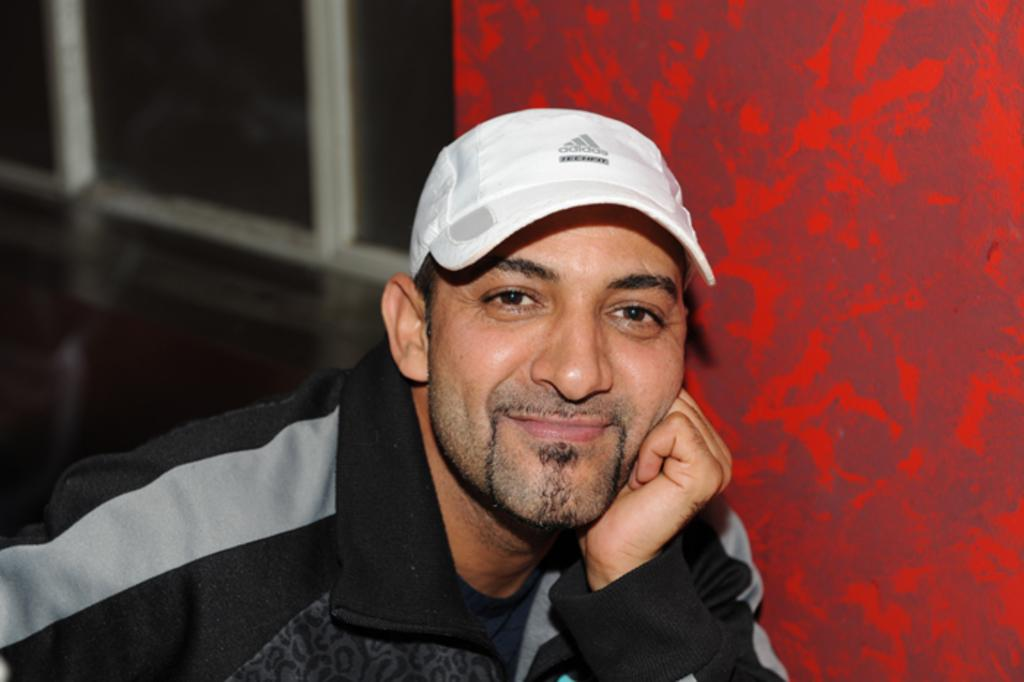What can be seen in the image that provides a view of the outside? There is a window in the image. Who is present in the image? There is a man in the image. What is the man wearing on his head? The man is wearing a white color cap. What color is the shirt the man is wearing? The man is wearing a black color shirt. What type of cushion is the man sitting on in the image? There is no cushion present in the image, nor is the man sitting down. How does the man's behavior change throughout the image? The image only shows a single moment in time, so it is impossible to determine any changes in the man's behavior. 